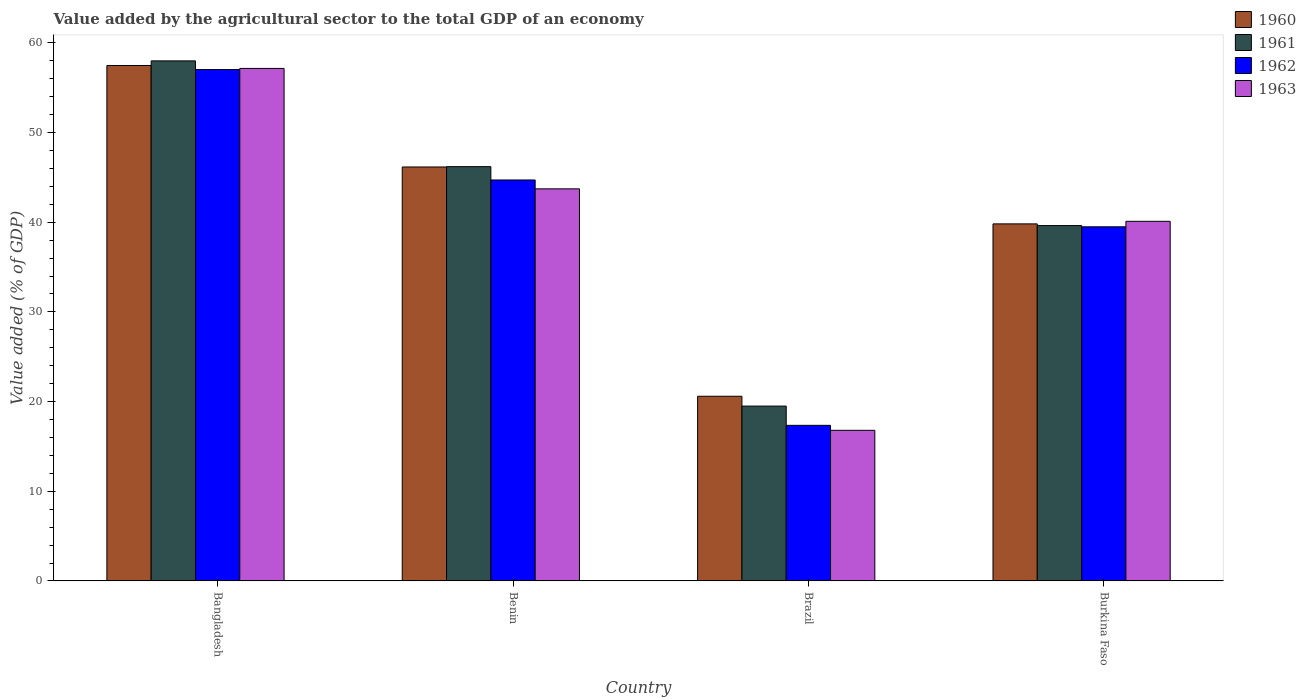How many different coloured bars are there?
Offer a very short reply. 4. Are the number of bars on each tick of the X-axis equal?
Keep it short and to the point. Yes. How many bars are there on the 3rd tick from the right?
Ensure brevity in your answer.  4. What is the label of the 3rd group of bars from the left?
Offer a very short reply. Brazil. What is the value added by the agricultural sector to the total GDP in 1961 in Brazil?
Keep it short and to the point. 19.5. Across all countries, what is the maximum value added by the agricultural sector to the total GDP in 1960?
Provide a succinct answer. 57.47. Across all countries, what is the minimum value added by the agricultural sector to the total GDP in 1963?
Your answer should be compact. 16.79. What is the total value added by the agricultural sector to the total GDP in 1962 in the graph?
Provide a succinct answer. 158.56. What is the difference between the value added by the agricultural sector to the total GDP in 1961 in Benin and that in Brazil?
Give a very brief answer. 26.7. What is the difference between the value added by the agricultural sector to the total GDP in 1960 in Bangladesh and the value added by the agricultural sector to the total GDP in 1961 in Brazil?
Your answer should be compact. 37.98. What is the average value added by the agricultural sector to the total GDP in 1962 per country?
Make the answer very short. 39.64. What is the difference between the value added by the agricultural sector to the total GDP of/in 1960 and value added by the agricultural sector to the total GDP of/in 1961 in Benin?
Offer a very short reply. -0.04. What is the ratio of the value added by the agricultural sector to the total GDP in 1961 in Brazil to that in Burkina Faso?
Make the answer very short. 0.49. Is the value added by the agricultural sector to the total GDP in 1961 in Benin less than that in Brazil?
Keep it short and to the point. No. What is the difference between the highest and the second highest value added by the agricultural sector to the total GDP in 1962?
Your response must be concise. 12.31. What is the difference between the highest and the lowest value added by the agricultural sector to the total GDP in 1960?
Offer a terse response. 36.88. Is the sum of the value added by the agricultural sector to the total GDP in 1963 in Benin and Brazil greater than the maximum value added by the agricultural sector to the total GDP in 1960 across all countries?
Offer a very short reply. Yes. What does the 4th bar from the left in Burkina Faso represents?
Ensure brevity in your answer.  1963. What does the 4th bar from the right in Brazil represents?
Offer a terse response. 1960. Are all the bars in the graph horizontal?
Provide a short and direct response. No. How many countries are there in the graph?
Give a very brief answer. 4. What is the difference between two consecutive major ticks on the Y-axis?
Your response must be concise. 10. Are the values on the major ticks of Y-axis written in scientific E-notation?
Keep it short and to the point. No. Does the graph contain any zero values?
Provide a succinct answer. No. Does the graph contain grids?
Make the answer very short. No. Where does the legend appear in the graph?
Offer a very short reply. Top right. What is the title of the graph?
Offer a very short reply. Value added by the agricultural sector to the total GDP of an economy. What is the label or title of the Y-axis?
Provide a short and direct response. Value added (% of GDP). What is the Value added (% of GDP) in 1960 in Bangladesh?
Make the answer very short. 57.47. What is the Value added (% of GDP) in 1961 in Bangladesh?
Your answer should be compact. 57.99. What is the Value added (% of GDP) in 1962 in Bangladesh?
Offer a very short reply. 57.02. What is the Value added (% of GDP) of 1963 in Bangladesh?
Your answer should be compact. 57.15. What is the Value added (% of GDP) in 1960 in Benin?
Offer a very short reply. 46.16. What is the Value added (% of GDP) of 1961 in Benin?
Ensure brevity in your answer.  46.19. What is the Value added (% of GDP) of 1962 in Benin?
Provide a succinct answer. 44.71. What is the Value added (% of GDP) of 1963 in Benin?
Give a very brief answer. 43.72. What is the Value added (% of GDP) of 1960 in Brazil?
Provide a short and direct response. 20.59. What is the Value added (% of GDP) in 1961 in Brazil?
Your answer should be very brief. 19.5. What is the Value added (% of GDP) in 1962 in Brazil?
Give a very brief answer. 17.35. What is the Value added (% of GDP) of 1963 in Brazil?
Give a very brief answer. 16.79. What is the Value added (% of GDP) of 1960 in Burkina Faso?
Provide a succinct answer. 39.81. What is the Value added (% of GDP) of 1961 in Burkina Faso?
Give a very brief answer. 39.62. What is the Value added (% of GDP) of 1962 in Burkina Faso?
Provide a succinct answer. 39.49. What is the Value added (% of GDP) in 1963 in Burkina Faso?
Your response must be concise. 40.1. Across all countries, what is the maximum Value added (% of GDP) in 1960?
Keep it short and to the point. 57.47. Across all countries, what is the maximum Value added (% of GDP) in 1961?
Offer a terse response. 57.99. Across all countries, what is the maximum Value added (% of GDP) in 1962?
Make the answer very short. 57.02. Across all countries, what is the maximum Value added (% of GDP) of 1963?
Keep it short and to the point. 57.15. Across all countries, what is the minimum Value added (% of GDP) of 1960?
Give a very brief answer. 20.59. Across all countries, what is the minimum Value added (% of GDP) in 1961?
Offer a very short reply. 19.5. Across all countries, what is the minimum Value added (% of GDP) of 1962?
Provide a succinct answer. 17.35. Across all countries, what is the minimum Value added (% of GDP) of 1963?
Your response must be concise. 16.79. What is the total Value added (% of GDP) in 1960 in the graph?
Keep it short and to the point. 164.04. What is the total Value added (% of GDP) of 1961 in the graph?
Give a very brief answer. 163.3. What is the total Value added (% of GDP) of 1962 in the graph?
Your answer should be very brief. 158.56. What is the total Value added (% of GDP) in 1963 in the graph?
Your response must be concise. 157.76. What is the difference between the Value added (% of GDP) in 1960 in Bangladesh and that in Benin?
Your answer should be compact. 11.32. What is the difference between the Value added (% of GDP) in 1961 in Bangladesh and that in Benin?
Provide a succinct answer. 11.79. What is the difference between the Value added (% of GDP) in 1962 in Bangladesh and that in Benin?
Make the answer very short. 12.31. What is the difference between the Value added (% of GDP) in 1963 in Bangladesh and that in Benin?
Your response must be concise. 13.43. What is the difference between the Value added (% of GDP) in 1960 in Bangladesh and that in Brazil?
Keep it short and to the point. 36.88. What is the difference between the Value added (% of GDP) in 1961 in Bangladesh and that in Brazil?
Offer a terse response. 38.49. What is the difference between the Value added (% of GDP) of 1962 in Bangladesh and that in Brazil?
Your answer should be very brief. 39.67. What is the difference between the Value added (% of GDP) in 1963 in Bangladesh and that in Brazil?
Provide a short and direct response. 40.35. What is the difference between the Value added (% of GDP) of 1960 in Bangladesh and that in Burkina Faso?
Your answer should be compact. 17.66. What is the difference between the Value added (% of GDP) of 1961 in Bangladesh and that in Burkina Faso?
Your answer should be very brief. 18.37. What is the difference between the Value added (% of GDP) in 1962 in Bangladesh and that in Burkina Faso?
Keep it short and to the point. 17.53. What is the difference between the Value added (% of GDP) in 1963 in Bangladesh and that in Burkina Faso?
Ensure brevity in your answer.  17.05. What is the difference between the Value added (% of GDP) in 1960 in Benin and that in Brazil?
Ensure brevity in your answer.  25.56. What is the difference between the Value added (% of GDP) of 1961 in Benin and that in Brazil?
Ensure brevity in your answer.  26.7. What is the difference between the Value added (% of GDP) of 1962 in Benin and that in Brazil?
Your answer should be compact. 27.36. What is the difference between the Value added (% of GDP) of 1963 in Benin and that in Brazil?
Offer a very short reply. 26.92. What is the difference between the Value added (% of GDP) in 1960 in Benin and that in Burkina Faso?
Offer a terse response. 6.35. What is the difference between the Value added (% of GDP) of 1961 in Benin and that in Burkina Faso?
Keep it short and to the point. 6.57. What is the difference between the Value added (% of GDP) in 1962 in Benin and that in Burkina Faso?
Keep it short and to the point. 5.22. What is the difference between the Value added (% of GDP) in 1963 in Benin and that in Burkina Faso?
Give a very brief answer. 3.62. What is the difference between the Value added (% of GDP) in 1960 in Brazil and that in Burkina Faso?
Keep it short and to the point. -19.22. What is the difference between the Value added (% of GDP) of 1961 in Brazil and that in Burkina Faso?
Your answer should be compact. -20.13. What is the difference between the Value added (% of GDP) of 1962 in Brazil and that in Burkina Faso?
Your answer should be very brief. -22.14. What is the difference between the Value added (% of GDP) in 1963 in Brazil and that in Burkina Faso?
Keep it short and to the point. -23.3. What is the difference between the Value added (% of GDP) of 1960 in Bangladesh and the Value added (% of GDP) of 1961 in Benin?
Offer a terse response. 11.28. What is the difference between the Value added (% of GDP) in 1960 in Bangladesh and the Value added (% of GDP) in 1962 in Benin?
Give a very brief answer. 12.77. What is the difference between the Value added (% of GDP) of 1960 in Bangladesh and the Value added (% of GDP) of 1963 in Benin?
Offer a terse response. 13.76. What is the difference between the Value added (% of GDP) in 1961 in Bangladesh and the Value added (% of GDP) in 1962 in Benin?
Offer a very short reply. 13.28. What is the difference between the Value added (% of GDP) in 1961 in Bangladesh and the Value added (% of GDP) in 1963 in Benin?
Ensure brevity in your answer.  14.27. What is the difference between the Value added (% of GDP) in 1962 in Bangladesh and the Value added (% of GDP) in 1963 in Benin?
Make the answer very short. 13.3. What is the difference between the Value added (% of GDP) in 1960 in Bangladesh and the Value added (% of GDP) in 1961 in Brazil?
Your response must be concise. 37.98. What is the difference between the Value added (% of GDP) in 1960 in Bangladesh and the Value added (% of GDP) in 1962 in Brazil?
Provide a succinct answer. 40.12. What is the difference between the Value added (% of GDP) of 1960 in Bangladesh and the Value added (% of GDP) of 1963 in Brazil?
Keep it short and to the point. 40.68. What is the difference between the Value added (% of GDP) of 1961 in Bangladesh and the Value added (% of GDP) of 1962 in Brazil?
Offer a terse response. 40.64. What is the difference between the Value added (% of GDP) in 1961 in Bangladesh and the Value added (% of GDP) in 1963 in Brazil?
Your answer should be compact. 41.19. What is the difference between the Value added (% of GDP) in 1962 in Bangladesh and the Value added (% of GDP) in 1963 in Brazil?
Offer a terse response. 40.22. What is the difference between the Value added (% of GDP) in 1960 in Bangladesh and the Value added (% of GDP) in 1961 in Burkina Faso?
Offer a very short reply. 17.85. What is the difference between the Value added (% of GDP) in 1960 in Bangladesh and the Value added (% of GDP) in 1962 in Burkina Faso?
Make the answer very short. 17.99. What is the difference between the Value added (% of GDP) of 1960 in Bangladesh and the Value added (% of GDP) of 1963 in Burkina Faso?
Offer a terse response. 17.38. What is the difference between the Value added (% of GDP) in 1961 in Bangladesh and the Value added (% of GDP) in 1962 in Burkina Faso?
Ensure brevity in your answer.  18.5. What is the difference between the Value added (% of GDP) in 1961 in Bangladesh and the Value added (% of GDP) in 1963 in Burkina Faso?
Offer a very short reply. 17.89. What is the difference between the Value added (% of GDP) in 1962 in Bangladesh and the Value added (% of GDP) in 1963 in Burkina Faso?
Provide a short and direct response. 16.92. What is the difference between the Value added (% of GDP) of 1960 in Benin and the Value added (% of GDP) of 1961 in Brazil?
Your answer should be very brief. 26.66. What is the difference between the Value added (% of GDP) in 1960 in Benin and the Value added (% of GDP) in 1962 in Brazil?
Offer a very short reply. 28.81. What is the difference between the Value added (% of GDP) of 1960 in Benin and the Value added (% of GDP) of 1963 in Brazil?
Give a very brief answer. 29.36. What is the difference between the Value added (% of GDP) in 1961 in Benin and the Value added (% of GDP) in 1962 in Brazil?
Provide a short and direct response. 28.84. What is the difference between the Value added (% of GDP) in 1961 in Benin and the Value added (% of GDP) in 1963 in Brazil?
Your answer should be very brief. 29.4. What is the difference between the Value added (% of GDP) of 1962 in Benin and the Value added (% of GDP) of 1963 in Brazil?
Provide a short and direct response. 27.92. What is the difference between the Value added (% of GDP) of 1960 in Benin and the Value added (% of GDP) of 1961 in Burkina Faso?
Offer a very short reply. 6.54. What is the difference between the Value added (% of GDP) in 1960 in Benin and the Value added (% of GDP) in 1962 in Burkina Faso?
Offer a very short reply. 6.67. What is the difference between the Value added (% of GDP) in 1960 in Benin and the Value added (% of GDP) in 1963 in Burkina Faso?
Offer a very short reply. 6.06. What is the difference between the Value added (% of GDP) in 1961 in Benin and the Value added (% of GDP) in 1962 in Burkina Faso?
Offer a terse response. 6.71. What is the difference between the Value added (% of GDP) of 1961 in Benin and the Value added (% of GDP) of 1963 in Burkina Faso?
Keep it short and to the point. 6.1. What is the difference between the Value added (% of GDP) in 1962 in Benin and the Value added (% of GDP) in 1963 in Burkina Faso?
Your response must be concise. 4.61. What is the difference between the Value added (% of GDP) in 1960 in Brazil and the Value added (% of GDP) in 1961 in Burkina Faso?
Provide a short and direct response. -19.03. What is the difference between the Value added (% of GDP) of 1960 in Brazil and the Value added (% of GDP) of 1962 in Burkina Faso?
Make the answer very short. -18.89. What is the difference between the Value added (% of GDP) in 1960 in Brazil and the Value added (% of GDP) in 1963 in Burkina Faso?
Your response must be concise. -19.51. What is the difference between the Value added (% of GDP) in 1961 in Brazil and the Value added (% of GDP) in 1962 in Burkina Faso?
Keep it short and to the point. -19.99. What is the difference between the Value added (% of GDP) of 1961 in Brazil and the Value added (% of GDP) of 1963 in Burkina Faso?
Give a very brief answer. -20.6. What is the difference between the Value added (% of GDP) of 1962 in Brazil and the Value added (% of GDP) of 1963 in Burkina Faso?
Offer a terse response. -22.75. What is the average Value added (% of GDP) of 1960 per country?
Offer a very short reply. 41.01. What is the average Value added (% of GDP) in 1961 per country?
Provide a succinct answer. 40.83. What is the average Value added (% of GDP) of 1962 per country?
Provide a short and direct response. 39.64. What is the average Value added (% of GDP) in 1963 per country?
Offer a very short reply. 39.44. What is the difference between the Value added (% of GDP) of 1960 and Value added (% of GDP) of 1961 in Bangladesh?
Your answer should be compact. -0.51. What is the difference between the Value added (% of GDP) in 1960 and Value added (% of GDP) in 1962 in Bangladesh?
Your response must be concise. 0.46. What is the difference between the Value added (% of GDP) of 1960 and Value added (% of GDP) of 1963 in Bangladesh?
Make the answer very short. 0.33. What is the difference between the Value added (% of GDP) of 1961 and Value added (% of GDP) of 1962 in Bangladesh?
Your answer should be very brief. 0.97. What is the difference between the Value added (% of GDP) in 1961 and Value added (% of GDP) in 1963 in Bangladesh?
Ensure brevity in your answer.  0.84. What is the difference between the Value added (% of GDP) in 1962 and Value added (% of GDP) in 1963 in Bangladesh?
Give a very brief answer. -0.13. What is the difference between the Value added (% of GDP) in 1960 and Value added (% of GDP) in 1961 in Benin?
Offer a very short reply. -0.04. What is the difference between the Value added (% of GDP) in 1960 and Value added (% of GDP) in 1962 in Benin?
Make the answer very short. 1.45. What is the difference between the Value added (% of GDP) of 1960 and Value added (% of GDP) of 1963 in Benin?
Keep it short and to the point. 2.44. What is the difference between the Value added (% of GDP) of 1961 and Value added (% of GDP) of 1962 in Benin?
Your answer should be very brief. 1.48. What is the difference between the Value added (% of GDP) in 1961 and Value added (% of GDP) in 1963 in Benin?
Your answer should be very brief. 2.48. What is the difference between the Value added (% of GDP) in 1962 and Value added (% of GDP) in 1963 in Benin?
Your response must be concise. 0.99. What is the difference between the Value added (% of GDP) of 1960 and Value added (% of GDP) of 1961 in Brazil?
Your answer should be very brief. 1.1. What is the difference between the Value added (% of GDP) of 1960 and Value added (% of GDP) of 1962 in Brazil?
Your response must be concise. 3.24. What is the difference between the Value added (% of GDP) of 1960 and Value added (% of GDP) of 1963 in Brazil?
Keep it short and to the point. 3.8. What is the difference between the Value added (% of GDP) in 1961 and Value added (% of GDP) in 1962 in Brazil?
Ensure brevity in your answer.  2.15. What is the difference between the Value added (% of GDP) of 1961 and Value added (% of GDP) of 1963 in Brazil?
Your answer should be compact. 2.7. What is the difference between the Value added (% of GDP) in 1962 and Value added (% of GDP) in 1963 in Brazil?
Your answer should be compact. 0.56. What is the difference between the Value added (% of GDP) in 1960 and Value added (% of GDP) in 1961 in Burkina Faso?
Your response must be concise. 0.19. What is the difference between the Value added (% of GDP) in 1960 and Value added (% of GDP) in 1962 in Burkina Faso?
Offer a terse response. 0.33. What is the difference between the Value added (% of GDP) of 1960 and Value added (% of GDP) of 1963 in Burkina Faso?
Provide a short and direct response. -0.29. What is the difference between the Value added (% of GDP) in 1961 and Value added (% of GDP) in 1962 in Burkina Faso?
Your answer should be compact. 0.14. What is the difference between the Value added (% of GDP) of 1961 and Value added (% of GDP) of 1963 in Burkina Faso?
Your answer should be compact. -0.48. What is the difference between the Value added (% of GDP) in 1962 and Value added (% of GDP) in 1963 in Burkina Faso?
Your answer should be compact. -0.61. What is the ratio of the Value added (% of GDP) in 1960 in Bangladesh to that in Benin?
Provide a short and direct response. 1.25. What is the ratio of the Value added (% of GDP) of 1961 in Bangladesh to that in Benin?
Your response must be concise. 1.26. What is the ratio of the Value added (% of GDP) of 1962 in Bangladesh to that in Benin?
Keep it short and to the point. 1.28. What is the ratio of the Value added (% of GDP) of 1963 in Bangladesh to that in Benin?
Keep it short and to the point. 1.31. What is the ratio of the Value added (% of GDP) in 1960 in Bangladesh to that in Brazil?
Give a very brief answer. 2.79. What is the ratio of the Value added (% of GDP) in 1961 in Bangladesh to that in Brazil?
Offer a terse response. 2.97. What is the ratio of the Value added (% of GDP) in 1962 in Bangladesh to that in Brazil?
Provide a succinct answer. 3.29. What is the ratio of the Value added (% of GDP) in 1963 in Bangladesh to that in Brazil?
Your answer should be compact. 3.4. What is the ratio of the Value added (% of GDP) of 1960 in Bangladesh to that in Burkina Faso?
Offer a terse response. 1.44. What is the ratio of the Value added (% of GDP) of 1961 in Bangladesh to that in Burkina Faso?
Ensure brevity in your answer.  1.46. What is the ratio of the Value added (% of GDP) in 1962 in Bangladesh to that in Burkina Faso?
Provide a succinct answer. 1.44. What is the ratio of the Value added (% of GDP) of 1963 in Bangladesh to that in Burkina Faso?
Provide a succinct answer. 1.43. What is the ratio of the Value added (% of GDP) of 1960 in Benin to that in Brazil?
Keep it short and to the point. 2.24. What is the ratio of the Value added (% of GDP) of 1961 in Benin to that in Brazil?
Your answer should be very brief. 2.37. What is the ratio of the Value added (% of GDP) in 1962 in Benin to that in Brazil?
Your answer should be very brief. 2.58. What is the ratio of the Value added (% of GDP) of 1963 in Benin to that in Brazil?
Provide a succinct answer. 2.6. What is the ratio of the Value added (% of GDP) in 1960 in Benin to that in Burkina Faso?
Provide a short and direct response. 1.16. What is the ratio of the Value added (% of GDP) of 1961 in Benin to that in Burkina Faso?
Provide a short and direct response. 1.17. What is the ratio of the Value added (% of GDP) in 1962 in Benin to that in Burkina Faso?
Give a very brief answer. 1.13. What is the ratio of the Value added (% of GDP) of 1963 in Benin to that in Burkina Faso?
Offer a very short reply. 1.09. What is the ratio of the Value added (% of GDP) in 1960 in Brazil to that in Burkina Faso?
Your answer should be very brief. 0.52. What is the ratio of the Value added (% of GDP) in 1961 in Brazil to that in Burkina Faso?
Offer a terse response. 0.49. What is the ratio of the Value added (% of GDP) in 1962 in Brazil to that in Burkina Faso?
Ensure brevity in your answer.  0.44. What is the ratio of the Value added (% of GDP) in 1963 in Brazil to that in Burkina Faso?
Your response must be concise. 0.42. What is the difference between the highest and the second highest Value added (% of GDP) in 1960?
Ensure brevity in your answer.  11.32. What is the difference between the highest and the second highest Value added (% of GDP) of 1961?
Offer a very short reply. 11.79. What is the difference between the highest and the second highest Value added (% of GDP) in 1962?
Provide a short and direct response. 12.31. What is the difference between the highest and the second highest Value added (% of GDP) of 1963?
Your response must be concise. 13.43. What is the difference between the highest and the lowest Value added (% of GDP) in 1960?
Your answer should be very brief. 36.88. What is the difference between the highest and the lowest Value added (% of GDP) in 1961?
Offer a very short reply. 38.49. What is the difference between the highest and the lowest Value added (% of GDP) in 1962?
Offer a terse response. 39.67. What is the difference between the highest and the lowest Value added (% of GDP) of 1963?
Provide a short and direct response. 40.35. 